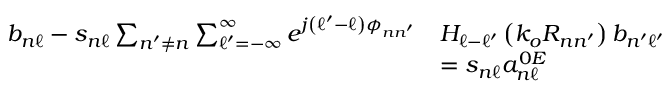<formula> <loc_0><loc_0><loc_500><loc_500>\begin{array} { r l } { b _ { n \ell } - s _ { n \ell } \sum _ { n ^ { \prime } \neq n } \sum _ { \ell ^ { \prime } = - \infty } ^ { \infty } e ^ { j \left ( \ell ^ { \prime } - \ell \right ) \phi _ { n n ^ { \prime } } } } & { H _ { \ell - \ell ^ { \prime } } \left ( k _ { o } R _ { n n ^ { \prime } } \right ) b _ { n ^ { \prime } \ell ^ { \prime } } } \\ & { = s _ { n \ell } a _ { n \ell } ^ { 0 E } } \end{array}</formula> 